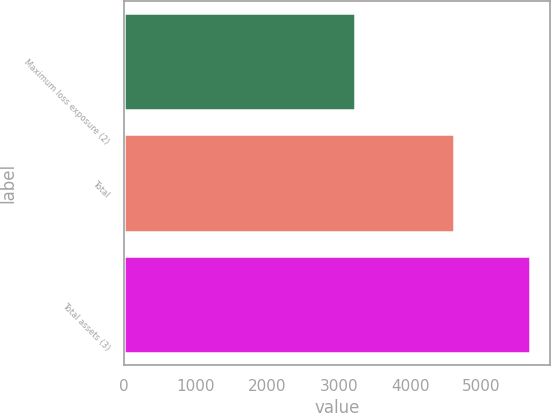Convert chart. <chart><loc_0><loc_0><loc_500><loc_500><bar_chart><fcel>Maximum loss exposure (2)<fcel>Total<fcel>Total assets (3)<nl><fcel>3222<fcel>4616<fcel>5671<nl></chart> 